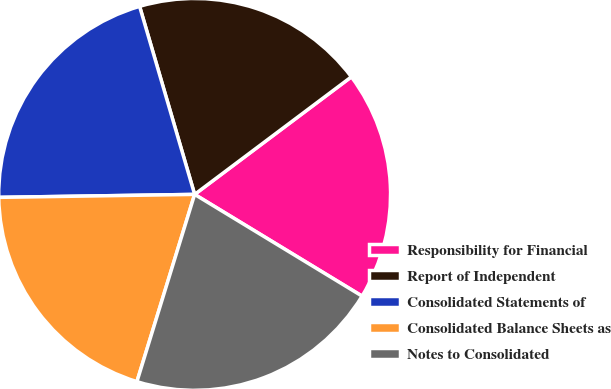<chart> <loc_0><loc_0><loc_500><loc_500><pie_chart><fcel>Responsibility for Financial<fcel>Report of Independent<fcel>Consolidated Statements of<fcel>Consolidated Balance Sheets as<fcel>Notes to Consolidated<nl><fcel>18.93%<fcel>19.29%<fcel>20.71%<fcel>20.0%<fcel>21.07%<nl></chart> 